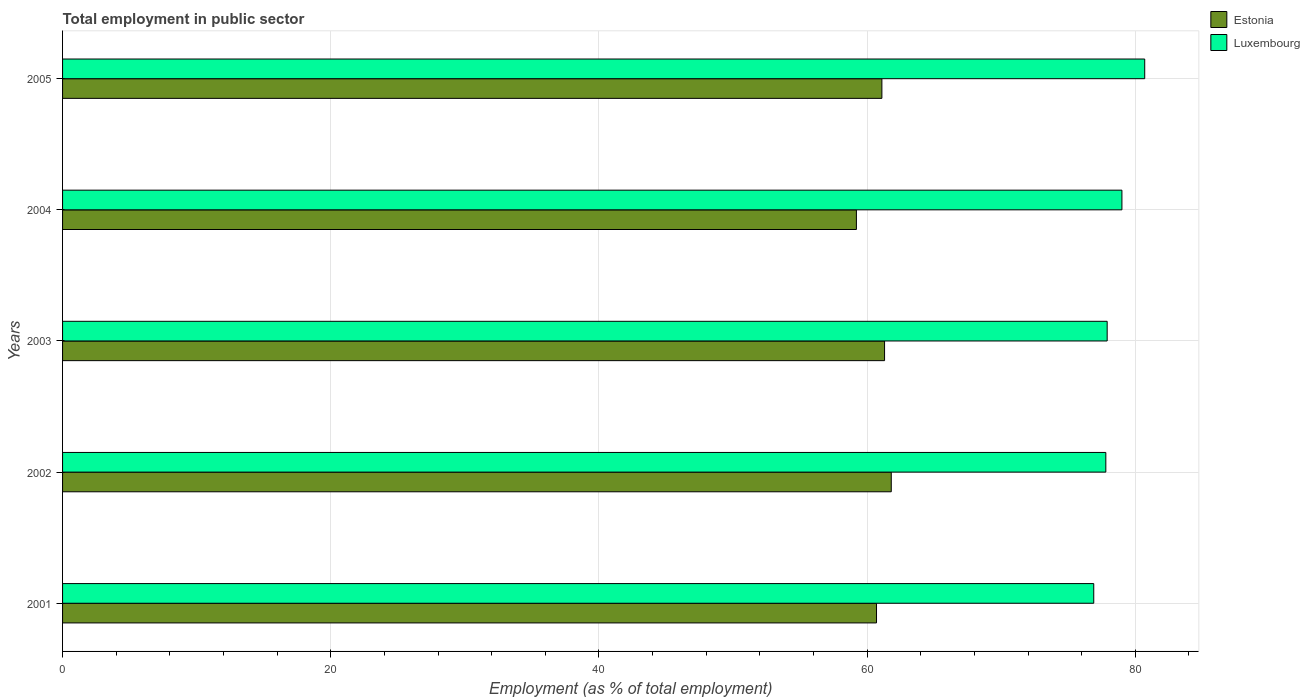Are the number of bars per tick equal to the number of legend labels?
Your response must be concise. Yes. How many bars are there on the 5th tick from the bottom?
Provide a succinct answer. 2. In how many cases, is the number of bars for a given year not equal to the number of legend labels?
Keep it short and to the point. 0. What is the employment in public sector in Luxembourg in 2003?
Your answer should be very brief. 77.9. Across all years, what is the maximum employment in public sector in Estonia?
Ensure brevity in your answer.  61.8. Across all years, what is the minimum employment in public sector in Luxembourg?
Make the answer very short. 76.9. What is the total employment in public sector in Luxembourg in the graph?
Offer a terse response. 392.3. What is the difference between the employment in public sector in Luxembourg in 2004 and that in 2005?
Provide a short and direct response. -1.7. What is the difference between the employment in public sector in Luxembourg in 2004 and the employment in public sector in Estonia in 2005?
Ensure brevity in your answer.  17.9. What is the average employment in public sector in Luxembourg per year?
Your answer should be very brief. 78.46. In the year 2002, what is the difference between the employment in public sector in Estonia and employment in public sector in Luxembourg?
Ensure brevity in your answer.  -16. What is the ratio of the employment in public sector in Luxembourg in 2001 to that in 2005?
Your response must be concise. 0.95. Is the difference between the employment in public sector in Estonia in 2002 and 2004 greater than the difference between the employment in public sector in Luxembourg in 2002 and 2004?
Provide a short and direct response. Yes. What is the difference between the highest and the second highest employment in public sector in Luxembourg?
Offer a terse response. 1.7. What is the difference between the highest and the lowest employment in public sector in Estonia?
Your answer should be compact. 2.6. In how many years, is the employment in public sector in Estonia greater than the average employment in public sector in Estonia taken over all years?
Your answer should be compact. 3. Is the sum of the employment in public sector in Luxembourg in 2001 and 2005 greater than the maximum employment in public sector in Estonia across all years?
Your answer should be very brief. Yes. What does the 1st bar from the top in 2004 represents?
Offer a terse response. Luxembourg. What does the 1st bar from the bottom in 2004 represents?
Give a very brief answer. Estonia. How many bars are there?
Ensure brevity in your answer.  10. Are all the bars in the graph horizontal?
Your answer should be very brief. Yes. Where does the legend appear in the graph?
Offer a terse response. Top right. How many legend labels are there?
Your answer should be very brief. 2. How are the legend labels stacked?
Keep it short and to the point. Vertical. What is the title of the graph?
Make the answer very short. Total employment in public sector. What is the label or title of the X-axis?
Offer a terse response. Employment (as % of total employment). What is the Employment (as % of total employment) of Estonia in 2001?
Offer a very short reply. 60.7. What is the Employment (as % of total employment) of Luxembourg in 2001?
Give a very brief answer. 76.9. What is the Employment (as % of total employment) in Estonia in 2002?
Give a very brief answer. 61.8. What is the Employment (as % of total employment) of Luxembourg in 2002?
Your answer should be very brief. 77.8. What is the Employment (as % of total employment) in Estonia in 2003?
Offer a very short reply. 61.3. What is the Employment (as % of total employment) in Luxembourg in 2003?
Give a very brief answer. 77.9. What is the Employment (as % of total employment) in Estonia in 2004?
Your answer should be compact. 59.2. What is the Employment (as % of total employment) in Luxembourg in 2004?
Your answer should be very brief. 79. What is the Employment (as % of total employment) in Estonia in 2005?
Keep it short and to the point. 61.1. What is the Employment (as % of total employment) in Luxembourg in 2005?
Keep it short and to the point. 80.7. Across all years, what is the maximum Employment (as % of total employment) in Estonia?
Offer a terse response. 61.8. Across all years, what is the maximum Employment (as % of total employment) of Luxembourg?
Your answer should be very brief. 80.7. Across all years, what is the minimum Employment (as % of total employment) of Estonia?
Keep it short and to the point. 59.2. Across all years, what is the minimum Employment (as % of total employment) in Luxembourg?
Make the answer very short. 76.9. What is the total Employment (as % of total employment) of Estonia in the graph?
Offer a very short reply. 304.1. What is the total Employment (as % of total employment) in Luxembourg in the graph?
Your response must be concise. 392.3. What is the difference between the Employment (as % of total employment) of Estonia in 2001 and that in 2002?
Offer a terse response. -1.1. What is the difference between the Employment (as % of total employment) in Luxembourg in 2001 and that in 2002?
Give a very brief answer. -0.9. What is the difference between the Employment (as % of total employment) of Estonia in 2001 and that in 2003?
Ensure brevity in your answer.  -0.6. What is the difference between the Employment (as % of total employment) of Estonia in 2001 and that in 2004?
Offer a terse response. 1.5. What is the difference between the Employment (as % of total employment) of Luxembourg in 2001 and that in 2004?
Provide a short and direct response. -2.1. What is the difference between the Employment (as % of total employment) in Estonia in 2001 and that in 2005?
Provide a succinct answer. -0.4. What is the difference between the Employment (as % of total employment) of Luxembourg in 2001 and that in 2005?
Make the answer very short. -3.8. What is the difference between the Employment (as % of total employment) in Luxembourg in 2002 and that in 2003?
Make the answer very short. -0.1. What is the difference between the Employment (as % of total employment) of Estonia in 2002 and that in 2004?
Offer a terse response. 2.6. What is the difference between the Employment (as % of total employment) of Estonia in 2002 and that in 2005?
Your answer should be very brief. 0.7. What is the difference between the Employment (as % of total employment) in Luxembourg in 2002 and that in 2005?
Give a very brief answer. -2.9. What is the difference between the Employment (as % of total employment) in Estonia in 2003 and that in 2004?
Offer a terse response. 2.1. What is the difference between the Employment (as % of total employment) in Estonia in 2003 and that in 2005?
Give a very brief answer. 0.2. What is the difference between the Employment (as % of total employment) in Estonia in 2004 and that in 2005?
Ensure brevity in your answer.  -1.9. What is the difference between the Employment (as % of total employment) of Estonia in 2001 and the Employment (as % of total employment) of Luxembourg in 2002?
Offer a very short reply. -17.1. What is the difference between the Employment (as % of total employment) in Estonia in 2001 and the Employment (as % of total employment) in Luxembourg in 2003?
Provide a short and direct response. -17.2. What is the difference between the Employment (as % of total employment) of Estonia in 2001 and the Employment (as % of total employment) of Luxembourg in 2004?
Offer a very short reply. -18.3. What is the difference between the Employment (as % of total employment) in Estonia in 2002 and the Employment (as % of total employment) in Luxembourg in 2003?
Offer a terse response. -16.1. What is the difference between the Employment (as % of total employment) in Estonia in 2002 and the Employment (as % of total employment) in Luxembourg in 2004?
Ensure brevity in your answer.  -17.2. What is the difference between the Employment (as % of total employment) of Estonia in 2002 and the Employment (as % of total employment) of Luxembourg in 2005?
Make the answer very short. -18.9. What is the difference between the Employment (as % of total employment) of Estonia in 2003 and the Employment (as % of total employment) of Luxembourg in 2004?
Make the answer very short. -17.7. What is the difference between the Employment (as % of total employment) in Estonia in 2003 and the Employment (as % of total employment) in Luxembourg in 2005?
Provide a short and direct response. -19.4. What is the difference between the Employment (as % of total employment) of Estonia in 2004 and the Employment (as % of total employment) of Luxembourg in 2005?
Make the answer very short. -21.5. What is the average Employment (as % of total employment) of Estonia per year?
Give a very brief answer. 60.82. What is the average Employment (as % of total employment) of Luxembourg per year?
Keep it short and to the point. 78.46. In the year 2001, what is the difference between the Employment (as % of total employment) in Estonia and Employment (as % of total employment) in Luxembourg?
Keep it short and to the point. -16.2. In the year 2003, what is the difference between the Employment (as % of total employment) of Estonia and Employment (as % of total employment) of Luxembourg?
Your answer should be compact. -16.6. In the year 2004, what is the difference between the Employment (as % of total employment) in Estonia and Employment (as % of total employment) in Luxembourg?
Give a very brief answer. -19.8. In the year 2005, what is the difference between the Employment (as % of total employment) in Estonia and Employment (as % of total employment) in Luxembourg?
Ensure brevity in your answer.  -19.6. What is the ratio of the Employment (as % of total employment) of Estonia in 2001 to that in 2002?
Offer a very short reply. 0.98. What is the ratio of the Employment (as % of total employment) in Luxembourg in 2001 to that in 2002?
Offer a terse response. 0.99. What is the ratio of the Employment (as % of total employment) of Estonia in 2001 to that in 2003?
Make the answer very short. 0.99. What is the ratio of the Employment (as % of total employment) of Luxembourg in 2001 to that in 2003?
Offer a terse response. 0.99. What is the ratio of the Employment (as % of total employment) in Estonia in 2001 to that in 2004?
Your answer should be very brief. 1.03. What is the ratio of the Employment (as % of total employment) in Luxembourg in 2001 to that in 2004?
Your answer should be very brief. 0.97. What is the ratio of the Employment (as % of total employment) in Estonia in 2001 to that in 2005?
Ensure brevity in your answer.  0.99. What is the ratio of the Employment (as % of total employment) in Luxembourg in 2001 to that in 2005?
Your answer should be compact. 0.95. What is the ratio of the Employment (as % of total employment) of Estonia in 2002 to that in 2003?
Your response must be concise. 1.01. What is the ratio of the Employment (as % of total employment) of Estonia in 2002 to that in 2004?
Your answer should be very brief. 1.04. What is the ratio of the Employment (as % of total employment) of Estonia in 2002 to that in 2005?
Give a very brief answer. 1.01. What is the ratio of the Employment (as % of total employment) in Luxembourg in 2002 to that in 2005?
Provide a succinct answer. 0.96. What is the ratio of the Employment (as % of total employment) of Estonia in 2003 to that in 2004?
Your response must be concise. 1.04. What is the ratio of the Employment (as % of total employment) in Luxembourg in 2003 to that in 2004?
Offer a terse response. 0.99. What is the ratio of the Employment (as % of total employment) in Luxembourg in 2003 to that in 2005?
Give a very brief answer. 0.97. What is the ratio of the Employment (as % of total employment) of Estonia in 2004 to that in 2005?
Your answer should be very brief. 0.97. What is the ratio of the Employment (as % of total employment) of Luxembourg in 2004 to that in 2005?
Make the answer very short. 0.98. What is the difference between the highest and the second highest Employment (as % of total employment) in Estonia?
Your answer should be very brief. 0.5. 